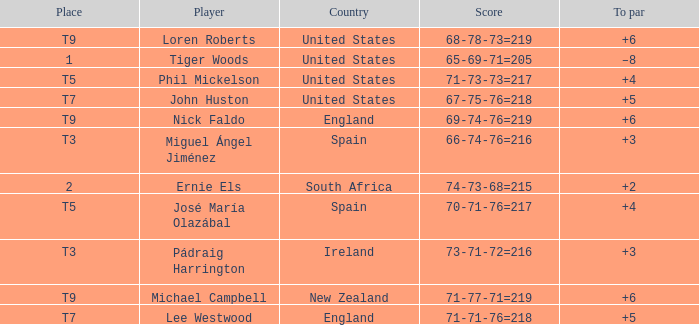What is Player, when Country is "England", and when Place is "T7"? Lee Westwood. 